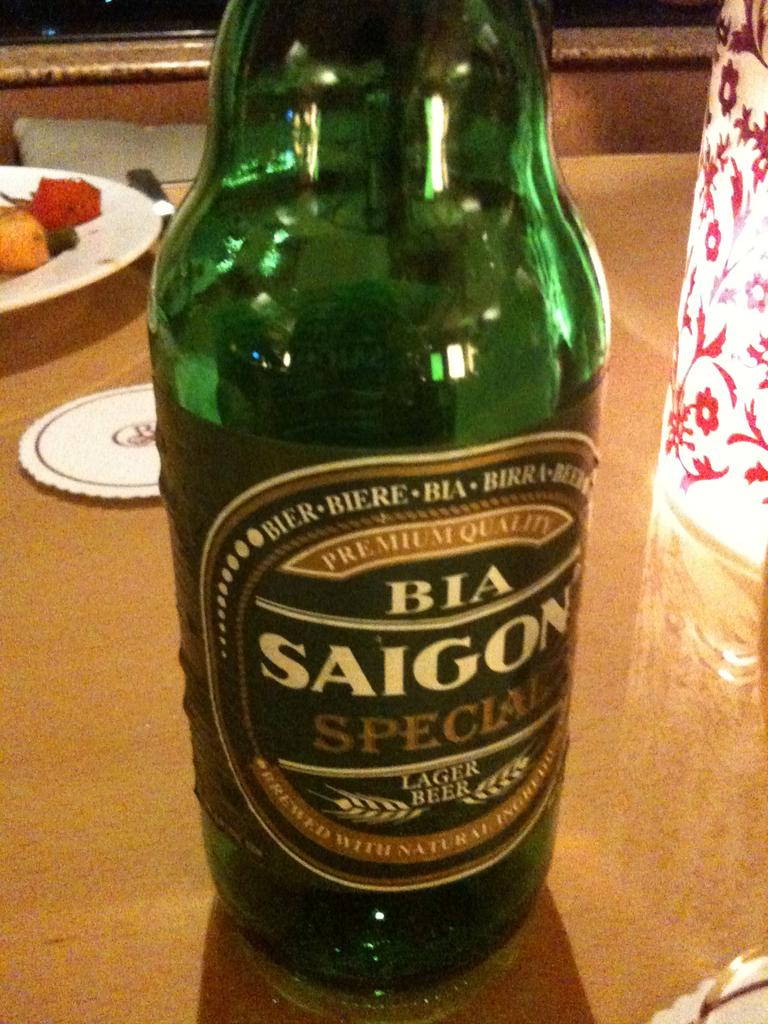What object can be seen in the image that is typically used for holding liquids? There is a glass bottle in the image. What can be found in the background of the image? There is food in a plate in the background of the image. What type of apparel is being worn by the circle in the image? There is no circle or apparel present in the image. 